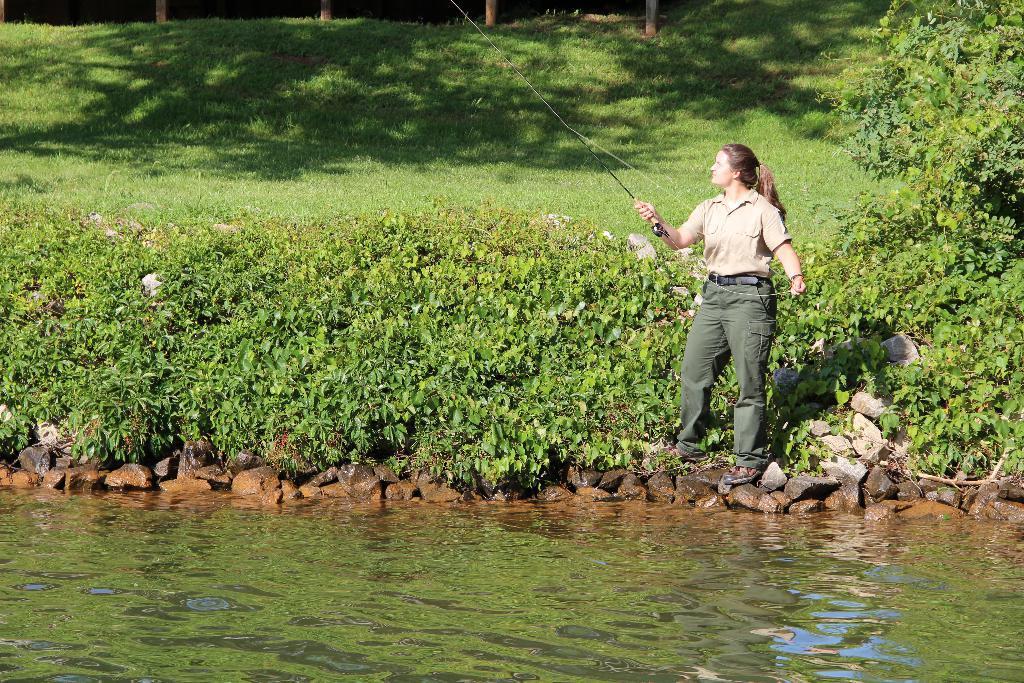Please provide a concise description of this image. In this picture I can see there is a woman standing here and she is holding a fishing rod and there are few plants, lake, grass and trees here. 